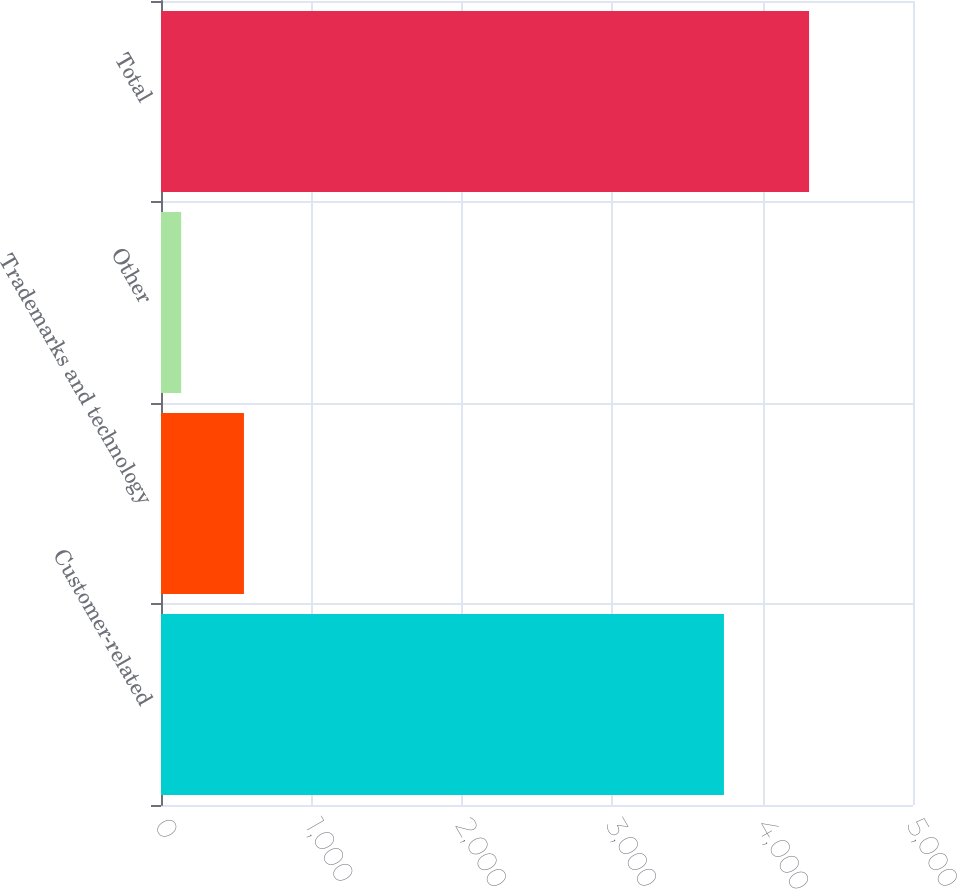<chart> <loc_0><loc_0><loc_500><loc_500><bar_chart><fcel>Customer-related<fcel>Trademarks and technology<fcel>Other<fcel>Total<nl><fcel>3743<fcel>551.5<fcel>134<fcel>4309<nl></chart> 